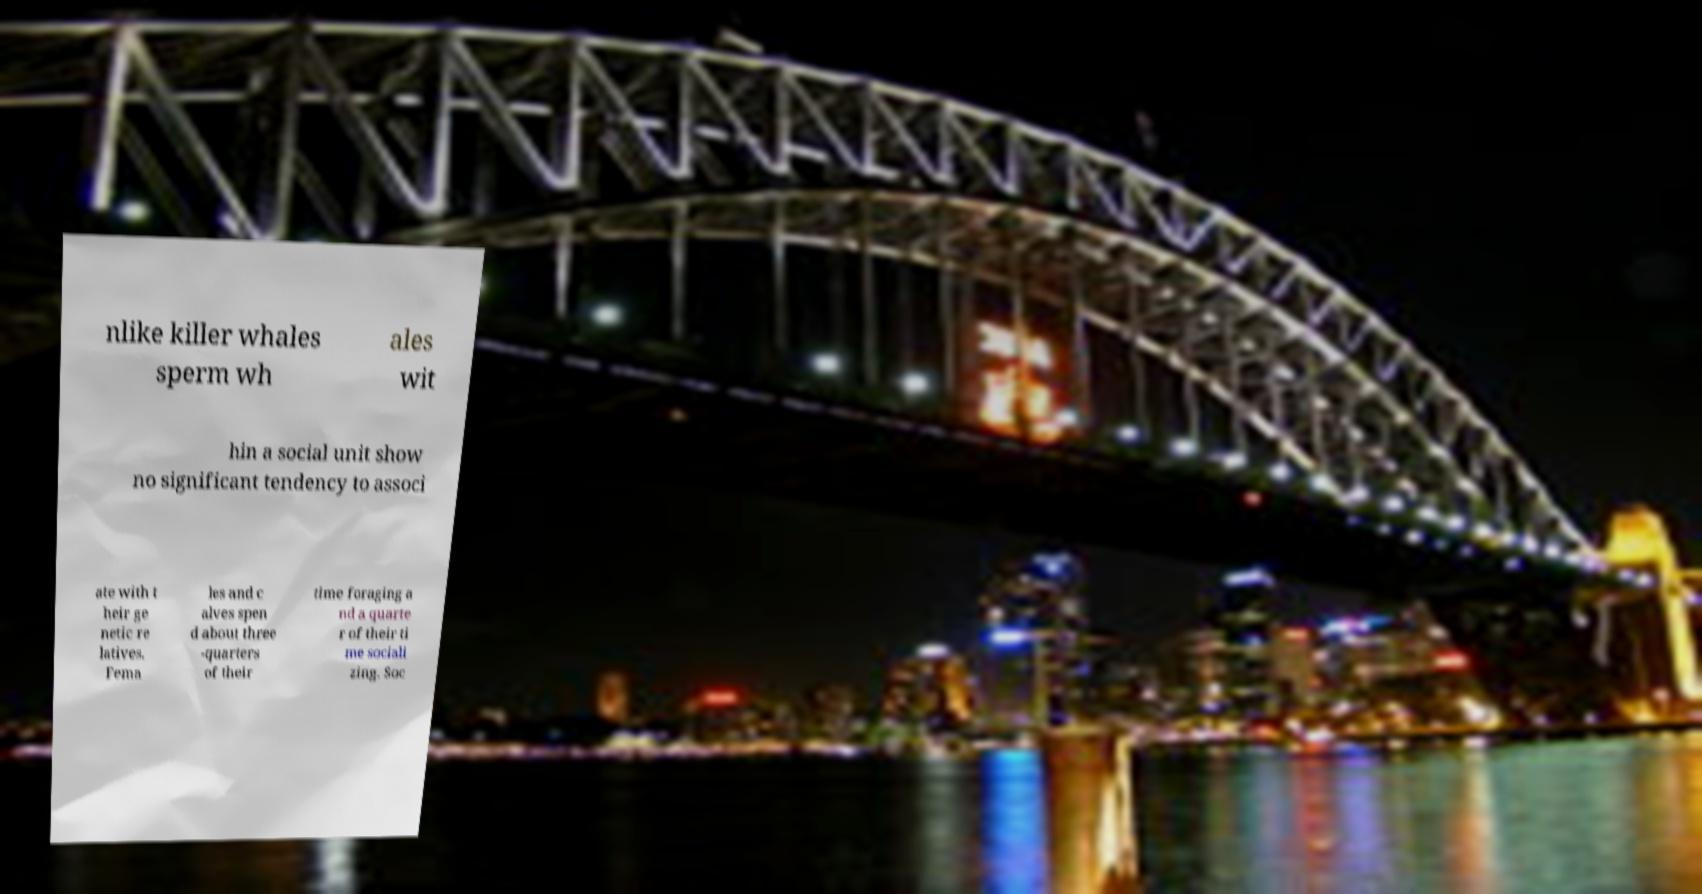For documentation purposes, I need the text within this image transcribed. Could you provide that? nlike killer whales sperm wh ales wit hin a social unit show no significant tendency to associ ate with t heir ge netic re latives. Fema les and c alves spen d about three -quarters of their time foraging a nd a quarte r of their ti me sociali zing. Soc 